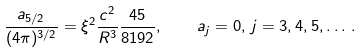<formula> <loc_0><loc_0><loc_500><loc_500>\frac { a _ { 5 / 2 } } { ( 4 \pi ) ^ { 3 / 2 } } = \xi ^ { 2 } \frac { c ^ { 2 } } { R ^ { 3 } } \frac { 4 5 } { 8 1 9 2 } , \quad a _ { j } = 0 , \, j = 3 , 4 , 5 , \dots \, { . }</formula> 